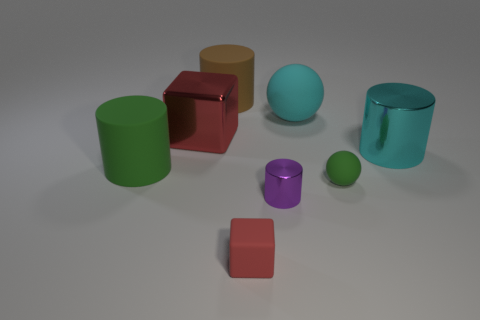Can you describe the lighting and shadows seen in the image? The image has soft, diffuse lighting that suggests an ambient light source, casting gentle shadows to the right of the objects, indicating a light source to the left out of view. 